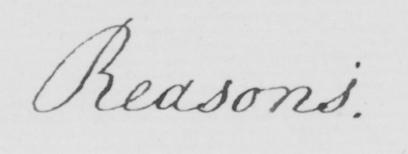Can you tell me what this handwritten text says? Reasons . 